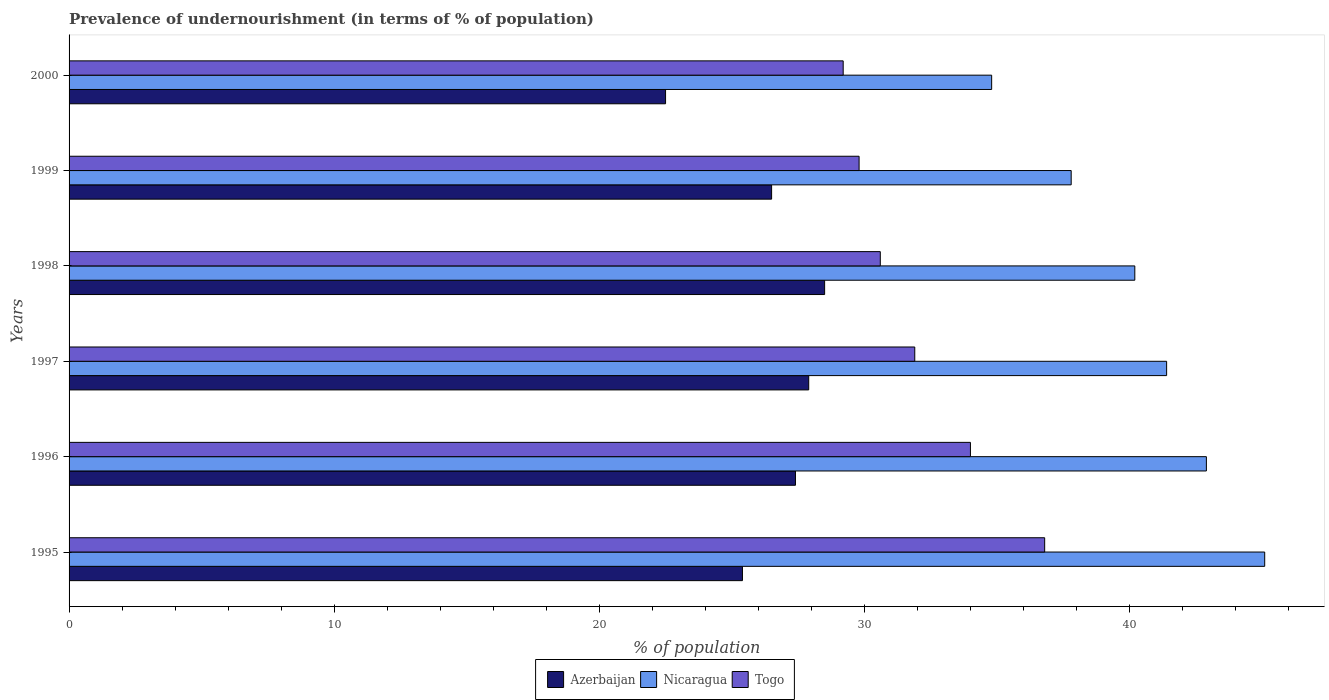How many different coloured bars are there?
Your answer should be very brief. 3. How many groups of bars are there?
Give a very brief answer. 6. Are the number of bars per tick equal to the number of legend labels?
Offer a terse response. Yes. Are the number of bars on each tick of the Y-axis equal?
Provide a succinct answer. Yes. In how many cases, is the number of bars for a given year not equal to the number of legend labels?
Your response must be concise. 0. What is the percentage of undernourished population in Azerbaijan in 1999?
Offer a very short reply. 26.5. Across all years, what is the maximum percentage of undernourished population in Nicaragua?
Your response must be concise. 45.1. Across all years, what is the minimum percentage of undernourished population in Nicaragua?
Your answer should be compact. 34.8. In which year was the percentage of undernourished population in Azerbaijan maximum?
Give a very brief answer. 1998. What is the total percentage of undernourished population in Azerbaijan in the graph?
Your answer should be compact. 158.2. What is the difference between the percentage of undernourished population in Nicaragua in 1997 and that in 1998?
Your answer should be very brief. 1.2. What is the difference between the percentage of undernourished population in Azerbaijan in 1996 and the percentage of undernourished population in Togo in 1995?
Ensure brevity in your answer.  -9.4. What is the average percentage of undernourished population in Azerbaijan per year?
Provide a succinct answer. 26.37. In the year 2000, what is the difference between the percentage of undernourished population in Nicaragua and percentage of undernourished population in Togo?
Ensure brevity in your answer.  5.6. What is the ratio of the percentage of undernourished population in Nicaragua in 1997 to that in 1998?
Your answer should be very brief. 1.03. Is the percentage of undernourished population in Nicaragua in 1996 less than that in 1998?
Offer a terse response. No. Is the difference between the percentage of undernourished population in Nicaragua in 1995 and 1999 greater than the difference between the percentage of undernourished population in Togo in 1995 and 1999?
Your response must be concise. Yes. What is the difference between the highest and the second highest percentage of undernourished population in Nicaragua?
Your answer should be compact. 2.2. What is the difference between the highest and the lowest percentage of undernourished population in Nicaragua?
Offer a terse response. 10.3. Is the sum of the percentage of undernourished population in Nicaragua in 1995 and 2000 greater than the maximum percentage of undernourished population in Togo across all years?
Your answer should be very brief. Yes. What does the 3rd bar from the top in 1998 represents?
Give a very brief answer. Azerbaijan. What does the 2nd bar from the bottom in 1996 represents?
Provide a short and direct response. Nicaragua. Is it the case that in every year, the sum of the percentage of undernourished population in Togo and percentage of undernourished population in Nicaragua is greater than the percentage of undernourished population in Azerbaijan?
Offer a terse response. Yes. Are the values on the major ticks of X-axis written in scientific E-notation?
Your response must be concise. No. Does the graph contain any zero values?
Offer a very short reply. No. How many legend labels are there?
Your answer should be very brief. 3. How are the legend labels stacked?
Offer a very short reply. Horizontal. What is the title of the graph?
Your response must be concise. Prevalence of undernourishment (in terms of % of population). What is the label or title of the X-axis?
Provide a short and direct response. % of population. What is the label or title of the Y-axis?
Your answer should be compact. Years. What is the % of population in Azerbaijan in 1995?
Make the answer very short. 25.4. What is the % of population of Nicaragua in 1995?
Offer a very short reply. 45.1. What is the % of population in Togo in 1995?
Your answer should be very brief. 36.8. What is the % of population of Azerbaijan in 1996?
Offer a very short reply. 27.4. What is the % of population in Nicaragua in 1996?
Keep it short and to the point. 42.9. What is the % of population in Azerbaijan in 1997?
Make the answer very short. 27.9. What is the % of population in Nicaragua in 1997?
Offer a very short reply. 41.4. What is the % of population of Togo in 1997?
Offer a very short reply. 31.9. What is the % of population in Azerbaijan in 1998?
Make the answer very short. 28.5. What is the % of population of Nicaragua in 1998?
Offer a terse response. 40.2. What is the % of population of Togo in 1998?
Make the answer very short. 30.6. What is the % of population in Nicaragua in 1999?
Your response must be concise. 37.8. What is the % of population of Togo in 1999?
Offer a very short reply. 29.8. What is the % of population of Nicaragua in 2000?
Your answer should be compact. 34.8. What is the % of population in Togo in 2000?
Provide a short and direct response. 29.2. Across all years, what is the maximum % of population of Nicaragua?
Your answer should be compact. 45.1. Across all years, what is the maximum % of population of Togo?
Make the answer very short. 36.8. Across all years, what is the minimum % of population in Nicaragua?
Your answer should be compact. 34.8. Across all years, what is the minimum % of population in Togo?
Offer a very short reply. 29.2. What is the total % of population in Azerbaijan in the graph?
Give a very brief answer. 158.2. What is the total % of population in Nicaragua in the graph?
Your response must be concise. 242.2. What is the total % of population of Togo in the graph?
Keep it short and to the point. 192.3. What is the difference between the % of population of Nicaragua in 1995 and that in 1996?
Your response must be concise. 2.2. What is the difference between the % of population in Togo in 1995 and that in 1996?
Give a very brief answer. 2.8. What is the difference between the % of population in Azerbaijan in 1995 and that in 1997?
Make the answer very short. -2.5. What is the difference between the % of population in Togo in 1995 and that in 1997?
Keep it short and to the point. 4.9. What is the difference between the % of population of Nicaragua in 1995 and that in 1998?
Make the answer very short. 4.9. What is the difference between the % of population of Togo in 1995 and that in 1998?
Your answer should be compact. 6.2. What is the difference between the % of population in Togo in 1995 and that in 1999?
Provide a succinct answer. 7. What is the difference between the % of population in Nicaragua in 1995 and that in 2000?
Keep it short and to the point. 10.3. What is the difference between the % of population of Togo in 1995 and that in 2000?
Give a very brief answer. 7.6. What is the difference between the % of population of Azerbaijan in 1996 and that in 1997?
Your answer should be compact. -0.5. What is the difference between the % of population in Nicaragua in 1996 and that in 1997?
Keep it short and to the point. 1.5. What is the difference between the % of population of Togo in 1996 and that in 1997?
Offer a very short reply. 2.1. What is the difference between the % of population of Azerbaijan in 1996 and that in 1998?
Your answer should be compact. -1.1. What is the difference between the % of population of Nicaragua in 1996 and that in 1998?
Offer a terse response. 2.7. What is the difference between the % of population of Togo in 1996 and that in 1998?
Make the answer very short. 3.4. What is the difference between the % of population of Azerbaijan in 1996 and that in 1999?
Your answer should be very brief. 0.9. What is the difference between the % of population of Nicaragua in 1996 and that in 1999?
Your answer should be very brief. 5.1. What is the difference between the % of population in Azerbaijan in 1996 and that in 2000?
Provide a short and direct response. 4.9. What is the difference between the % of population of Togo in 1996 and that in 2000?
Keep it short and to the point. 4.8. What is the difference between the % of population of Togo in 1997 and that in 1998?
Offer a very short reply. 1.3. What is the difference between the % of population in Togo in 1997 and that in 1999?
Keep it short and to the point. 2.1. What is the difference between the % of population of Azerbaijan in 1997 and that in 2000?
Offer a very short reply. 5.4. What is the difference between the % of population of Azerbaijan in 1998 and that in 1999?
Provide a short and direct response. 2. What is the difference between the % of population in Azerbaijan in 1998 and that in 2000?
Make the answer very short. 6. What is the difference between the % of population in Nicaragua in 1998 and that in 2000?
Your answer should be very brief. 5.4. What is the difference between the % of population of Togo in 1998 and that in 2000?
Give a very brief answer. 1.4. What is the difference between the % of population of Azerbaijan in 1999 and that in 2000?
Keep it short and to the point. 4. What is the difference between the % of population in Azerbaijan in 1995 and the % of population in Nicaragua in 1996?
Your response must be concise. -17.5. What is the difference between the % of population in Azerbaijan in 1995 and the % of population in Togo in 1996?
Provide a succinct answer. -8.6. What is the difference between the % of population in Nicaragua in 1995 and the % of population in Togo in 1996?
Make the answer very short. 11.1. What is the difference between the % of population of Azerbaijan in 1995 and the % of population of Nicaragua in 1997?
Make the answer very short. -16. What is the difference between the % of population in Azerbaijan in 1995 and the % of population in Togo in 1997?
Ensure brevity in your answer.  -6.5. What is the difference between the % of population in Azerbaijan in 1995 and the % of population in Nicaragua in 1998?
Give a very brief answer. -14.8. What is the difference between the % of population of Nicaragua in 1995 and the % of population of Togo in 1998?
Your answer should be very brief. 14.5. What is the difference between the % of population of Azerbaijan in 1995 and the % of population of Nicaragua in 1999?
Offer a terse response. -12.4. What is the difference between the % of population in Azerbaijan in 1995 and the % of population in Togo in 1999?
Provide a short and direct response. -4.4. What is the difference between the % of population in Nicaragua in 1995 and the % of population in Togo in 1999?
Offer a very short reply. 15.3. What is the difference between the % of population in Azerbaijan in 1995 and the % of population in Nicaragua in 2000?
Make the answer very short. -9.4. What is the difference between the % of population of Nicaragua in 1995 and the % of population of Togo in 2000?
Your answer should be compact. 15.9. What is the difference between the % of population in Nicaragua in 1996 and the % of population in Togo in 1997?
Ensure brevity in your answer.  11. What is the difference between the % of population in Azerbaijan in 1996 and the % of population in Nicaragua in 1999?
Offer a very short reply. -10.4. What is the difference between the % of population in Azerbaijan in 1996 and the % of population in Togo in 1999?
Offer a very short reply. -2.4. What is the difference between the % of population in Azerbaijan in 1996 and the % of population in Nicaragua in 2000?
Offer a terse response. -7.4. What is the difference between the % of population of Azerbaijan in 1996 and the % of population of Togo in 2000?
Offer a very short reply. -1.8. What is the difference between the % of population of Nicaragua in 1996 and the % of population of Togo in 2000?
Offer a very short reply. 13.7. What is the difference between the % of population in Azerbaijan in 1997 and the % of population in Togo in 1998?
Your response must be concise. -2.7. What is the difference between the % of population in Nicaragua in 1997 and the % of population in Togo in 1998?
Offer a very short reply. 10.8. What is the difference between the % of population in Azerbaijan in 1997 and the % of population in Nicaragua in 1999?
Keep it short and to the point. -9.9. What is the difference between the % of population in Nicaragua in 1997 and the % of population in Togo in 1999?
Your answer should be compact. 11.6. What is the difference between the % of population in Azerbaijan in 1997 and the % of population in Nicaragua in 2000?
Offer a very short reply. -6.9. What is the difference between the % of population of Azerbaijan in 1998 and the % of population of Nicaragua in 1999?
Offer a very short reply. -9.3. What is the difference between the % of population in Azerbaijan in 1998 and the % of population in Nicaragua in 2000?
Offer a terse response. -6.3. What is the difference between the % of population of Azerbaijan in 1998 and the % of population of Togo in 2000?
Provide a short and direct response. -0.7. What is the difference between the % of population in Azerbaijan in 1999 and the % of population in Nicaragua in 2000?
Offer a terse response. -8.3. What is the average % of population of Azerbaijan per year?
Provide a short and direct response. 26.37. What is the average % of population in Nicaragua per year?
Your answer should be compact. 40.37. What is the average % of population of Togo per year?
Offer a terse response. 32.05. In the year 1995, what is the difference between the % of population of Azerbaijan and % of population of Nicaragua?
Offer a terse response. -19.7. In the year 1996, what is the difference between the % of population in Azerbaijan and % of population in Nicaragua?
Provide a short and direct response. -15.5. In the year 1997, what is the difference between the % of population in Azerbaijan and % of population in Nicaragua?
Offer a very short reply. -13.5. In the year 1997, what is the difference between the % of population in Nicaragua and % of population in Togo?
Your answer should be very brief. 9.5. In the year 1998, what is the difference between the % of population in Azerbaijan and % of population in Togo?
Provide a short and direct response. -2.1. In the year 1999, what is the difference between the % of population of Azerbaijan and % of population of Nicaragua?
Your response must be concise. -11.3. In the year 2000, what is the difference between the % of population of Nicaragua and % of population of Togo?
Provide a succinct answer. 5.6. What is the ratio of the % of population of Azerbaijan in 1995 to that in 1996?
Make the answer very short. 0.93. What is the ratio of the % of population of Nicaragua in 1995 to that in 1996?
Ensure brevity in your answer.  1.05. What is the ratio of the % of population of Togo in 1995 to that in 1996?
Ensure brevity in your answer.  1.08. What is the ratio of the % of population of Azerbaijan in 1995 to that in 1997?
Offer a very short reply. 0.91. What is the ratio of the % of population in Nicaragua in 1995 to that in 1997?
Offer a very short reply. 1.09. What is the ratio of the % of population in Togo in 1995 to that in 1997?
Give a very brief answer. 1.15. What is the ratio of the % of population of Azerbaijan in 1995 to that in 1998?
Offer a very short reply. 0.89. What is the ratio of the % of population in Nicaragua in 1995 to that in 1998?
Your response must be concise. 1.12. What is the ratio of the % of population in Togo in 1995 to that in 1998?
Offer a terse response. 1.2. What is the ratio of the % of population in Azerbaijan in 1995 to that in 1999?
Your answer should be compact. 0.96. What is the ratio of the % of population of Nicaragua in 1995 to that in 1999?
Offer a very short reply. 1.19. What is the ratio of the % of population of Togo in 1995 to that in 1999?
Provide a short and direct response. 1.23. What is the ratio of the % of population of Azerbaijan in 1995 to that in 2000?
Provide a succinct answer. 1.13. What is the ratio of the % of population in Nicaragua in 1995 to that in 2000?
Provide a short and direct response. 1.3. What is the ratio of the % of population in Togo in 1995 to that in 2000?
Keep it short and to the point. 1.26. What is the ratio of the % of population of Azerbaijan in 1996 to that in 1997?
Provide a short and direct response. 0.98. What is the ratio of the % of population of Nicaragua in 1996 to that in 1997?
Your answer should be compact. 1.04. What is the ratio of the % of population in Togo in 1996 to that in 1997?
Your answer should be compact. 1.07. What is the ratio of the % of population of Azerbaijan in 1996 to that in 1998?
Give a very brief answer. 0.96. What is the ratio of the % of population in Nicaragua in 1996 to that in 1998?
Offer a very short reply. 1.07. What is the ratio of the % of population of Azerbaijan in 1996 to that in 1999?
Provide a short and direct response. 1.03. What is the ratio of the % of population in Nicaragua in 1996 to that in 1999?
Make the answer very short. 1.13. What is the ratio of the % of population of Togo in 1996 to that in 1999?
Your response must be concise. 1.14. What is the ratio of the % of population of Azerbaijan in 1996 to that in 2000?
Provide a short and direct response. 1.22. What is the ratio of the % of population in Nicaragua in 1996 to that in 2000?
Your answer should be compact. 1.23. What is the ratio of the % of population in Togo in 1996 to that in 2000?
Your answer should be very brief. 1.16. What is the ratio of the % of population of Azerbaijan in 1997 to that in 1998?
Your answer should be compact. 0.98. What is the ratio of the % of population in Nicaragua in 1997 to that in 1998?
Your answer should be compact. 1.03. What is the ratio of the % of population in Togo in 1997 to that in 1998?
Provide a succinct answer. 1.04. What is the ratio of the % of population of Azerbaijan in 1997 to that in 1999?
Ensure brevity in your answer.  1.05. What is the ratio of the % of population in Nicaragua in 1997 to that in 1999?
Ensure brevity in your answer.  1.1. What is the ratio of the % of population in Togo in 1997 to that in 1999?
Make the answer very short. 1.07. What is the ratio of the % of population in Azerbaijan in 1997 to that in 2000?
Ensure brevity in your answer.  1.24. What is the ratio of the % of population of Nicaragua in 1997 to that in 2000?
Offer a very short reply. 1.19. What is the ratio of the % of population in Togo in 1997 to that in 2000?
Your answer should be compact. 1.09. What is the ratio of the % of population in Azerbaijan in 1998 to that in 1999?
Your response must be concise. 1.08. What is the ratio of the % of population of Nicaragua in 1998 to that in 1999?
Ensure brevity in your answer.  1.06. What is the ratio of the % of population in Togo in 1998 to that in 1999?
Your answer should be very brief. 1.03. What is the ratio of the % of population in Azerbaijan in 1998 to that in 2000?
Ensure brevity in your answer.  1.27. What is the ratio of the % of population of Nicaragua in 1998 to that in 2000?
Your answer should be very brief. 1.16. What is the ratio of the % of population in Togo in 1998 to that in 2000?
Your response must be concise. 1.05. What is the ratio of the % of population of Azerbaijan in 1999 to that in 2000?
Give a very brief answer. 1.18. What is the ratio of the % of population of Nicaragua in 1999 to that in 2000?
Give a very brief answer. 1.09. What is the ratio of the % of population in Togo in 1999 to that in 2000?
Ensure brevity in your answer.  1.02. What is the difference between the highest and the second highest % of population of Nicaragua?
Provide a succinct answer. 2.2. What is the difference between the highest and the second highest % of population in Togo?
Your answer should be very brief. 2.8. What is the difference between the highest and the lowest % of population of Nicaragua?
Provide a short and direct response. 10.3. What is the difference between the highest and the lowest % of population of Togo?
Offer a very short reply. 7.6. 